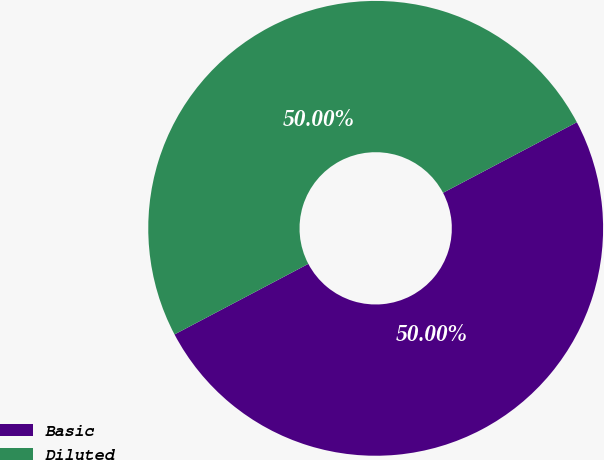<chart> <loc_0><loc_0><loc_500><loc_500><pie_chart><fcel>Basic<fcel>Diluted<nl><fcel>50.0%<fcel>50.0%<nl></chart> 